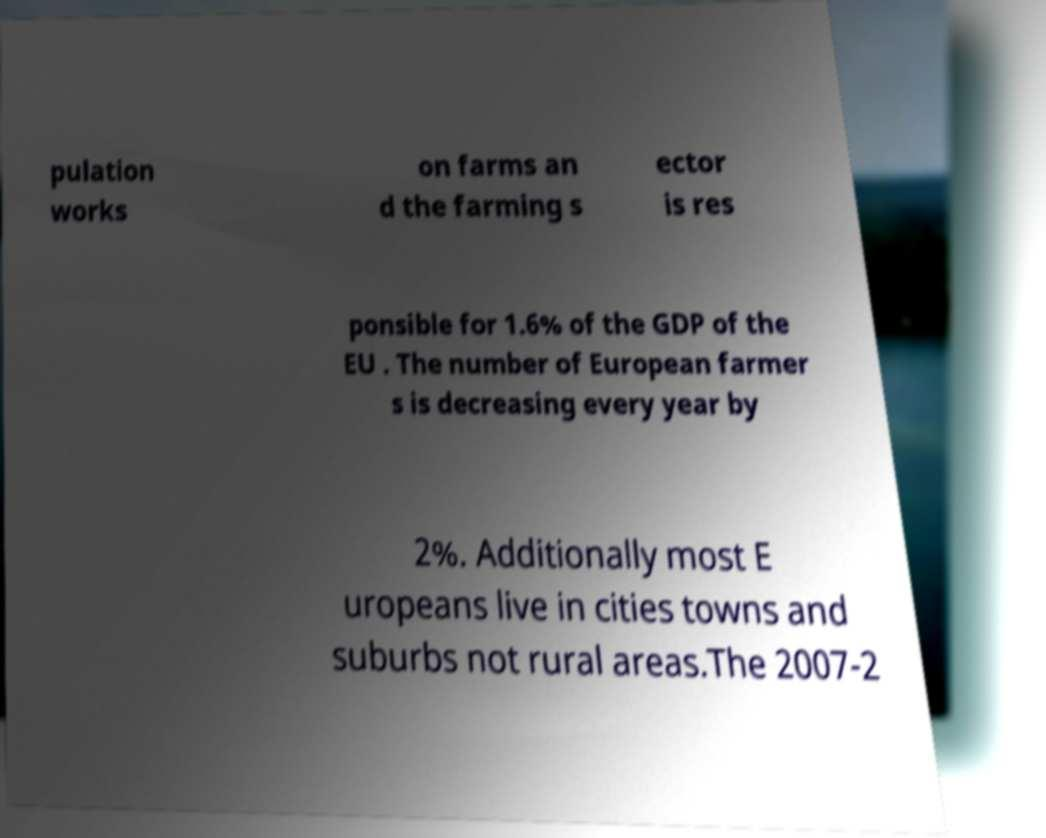For documentation purposes, I need the text within this image transcribed. Could you provide that? pulation works on farms an d the farming s ector is res ponsible for 1.6% of the GDP of the EU . The number of European farmer s is decreasing every year by 2%. Additionally most E uropeans live in cities towns and suburbs not rural areas.The 2007-2 